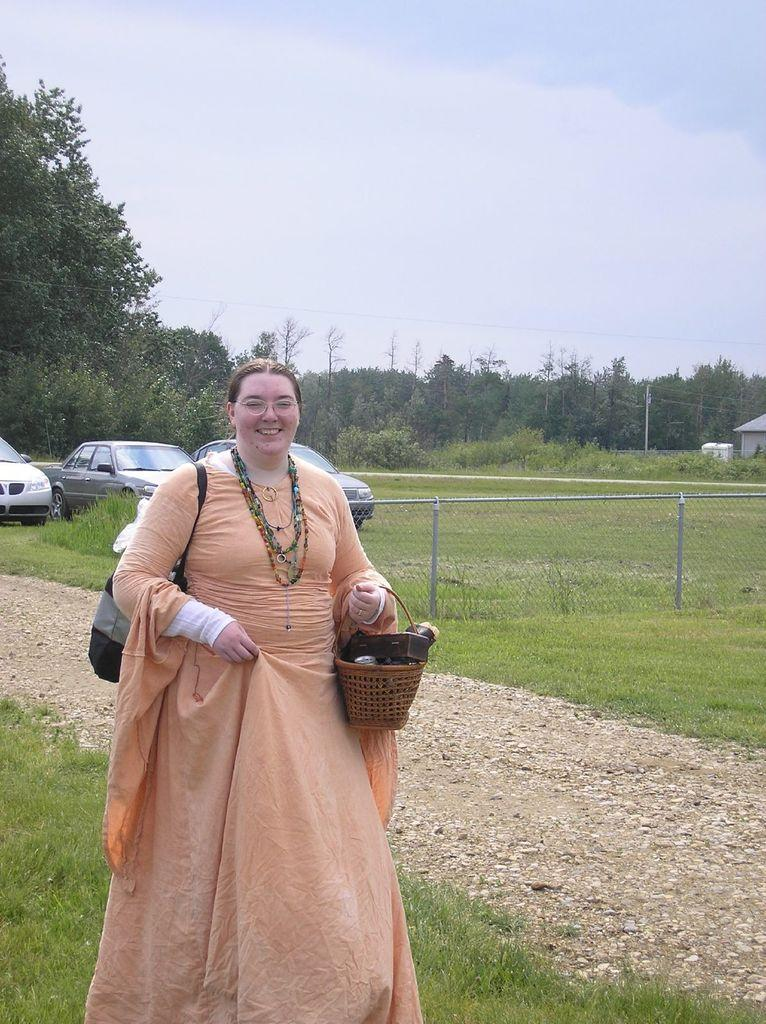What is the main subject of the image? There is a woman in the image. What is the woman doing in the image? The woman is standing in the image. What is the woman carrying in the image? The woman is carrying a bag and a basket in the image. What can be seen in the background of the image? There are vehicles on the grass, fencing, and a house in the background of the image. What type of adjustment can be seen being made to the drawer in the image? There is no drawer present in the image, so no adjustment can be observed. 